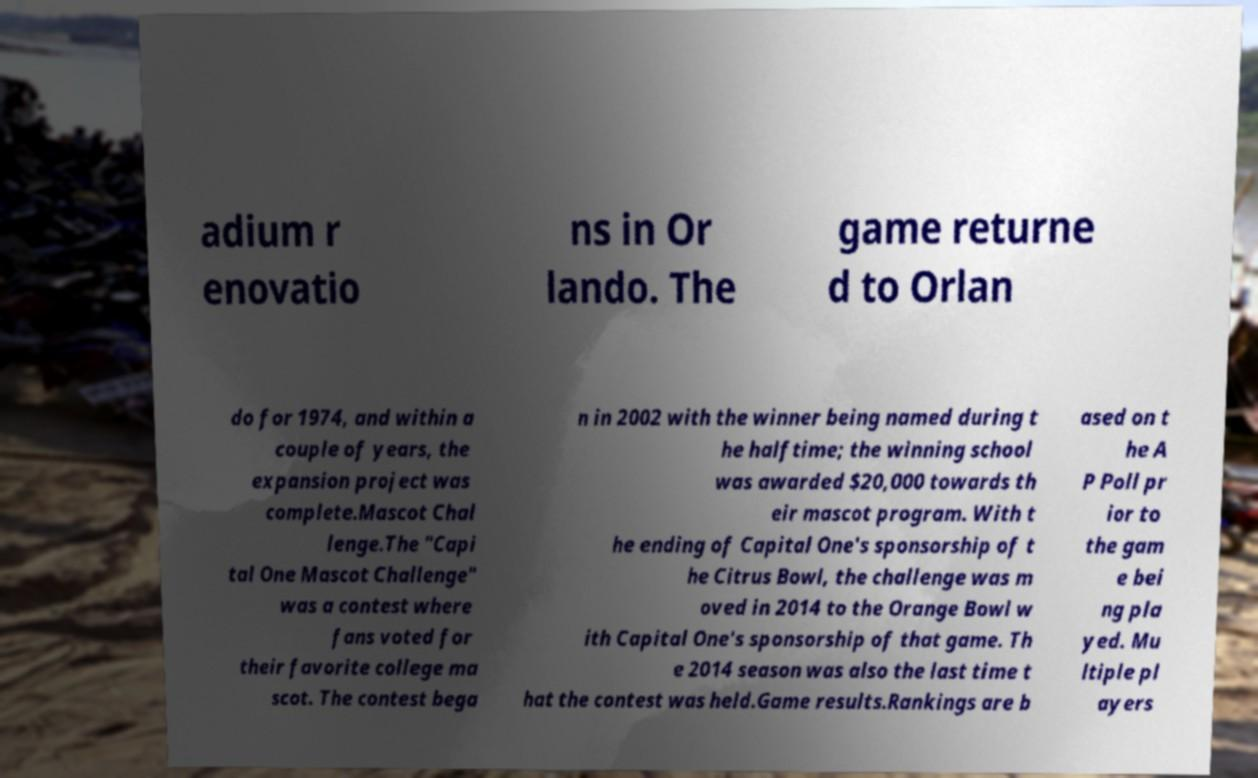Can you accurately transcribe the text from the provided image for me? adium r enovatio ns in Or lando. The game returne d to Orlan do for 1974, and within a couple of years, the expansion project was complete.Mascot Chal lenge.The "Capi tal One Mascot Challenge" was a contest where fans voted for their favorite college ma scot. The contest bega n in 2002 with the winner being named during t he halftime; the winning school was awarded $20,000 towards th eir mascot program. With t he ending of Capital One's sponsorship of t he Citrus Bowl, the challenge was m oved in 2014 to the Orange Bowl w ith Capital One's sponsorship of that game. Th e 2014 season was also the last time t hat the contest was held.Game results.Rankings are b ased on t he A P Poll pr ior to the gam e bei ng pla yed. Mu ltiple pl ayers 